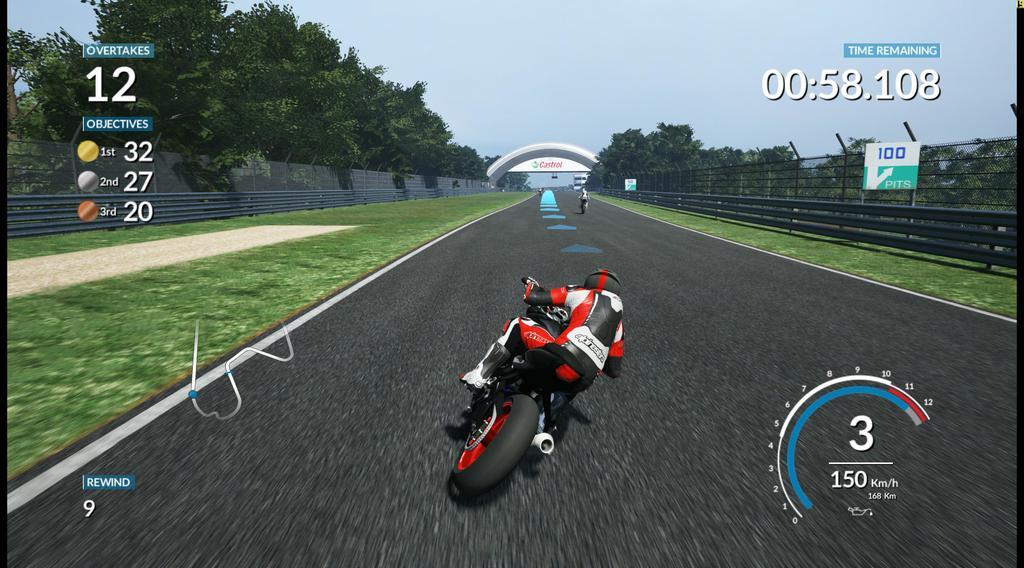Please provide a concise description of this image. In this animated picture two persons are riding the bikes on the road. Bottom of image person is wearing helmet. There is an arch at the middle of image. Left side there is a fence, behind there are few trees. Left side there is some text. Right side there is fence, behind there are few trees. Right top there is some text. Top of image there is sky. 